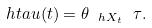Convert formula to latex. <formula><loc_0><loc_0><loc_500><loc_500>\ h t a u ( t ) = \theta _ { \ h X _ { t } } \ \tau .</formula> 